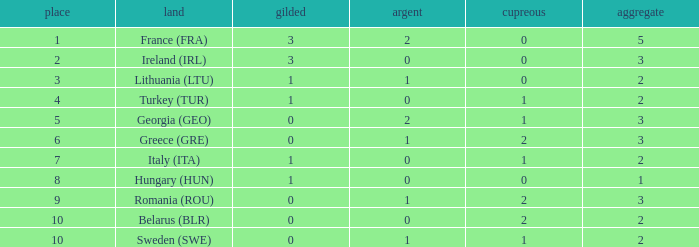What's the total of Sweden (SWE) having less than 1 silver? None. 